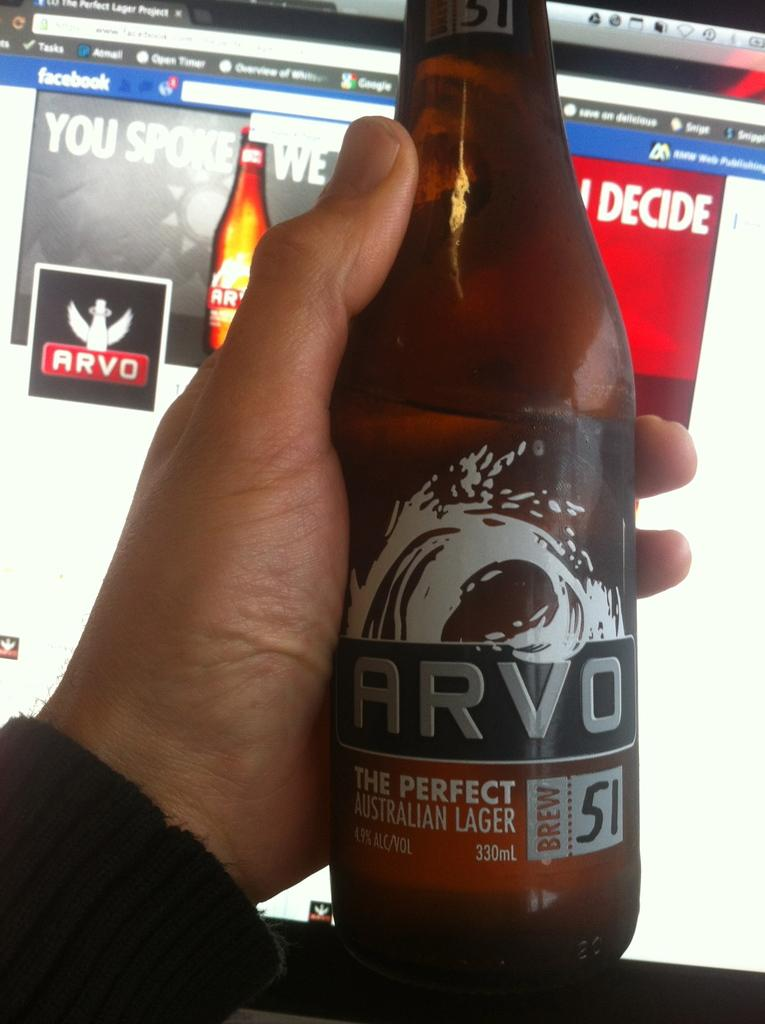<image>
Offer a succinct explanation of the picture presented. A brown bottle of beer that is labeled the best Australian Lager. 